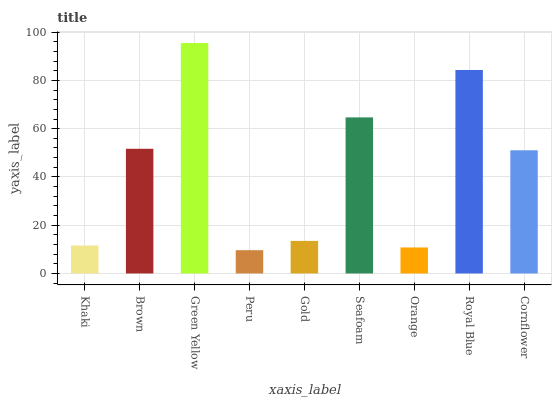Is Peru the minimum?
Answer yes or no. Yes. Is Green Yellow the maximum?
Answer yes or no. Yes. Is Brown the minimum?
Answer yes or no. No. Is Brown the maximum?
Answer yes or no. No. Is Brown greater than Khaki?
Answer yes or no. Yes. Is Khaki less than Brown?
Answer yes or no. Yes. Is Khaki greater than Brown?
Answer yes or no. No. Is Brown less than Khaki?
Answer yes or no. No. Is Cornflower the high median?
Answer yes or no. Yes. Is Cornflower the low median?
Answer yes or no. Yes. Is Brown the high median?
Answer yes or no. No. Is Gold the low median?
Answer yes or no. No. 